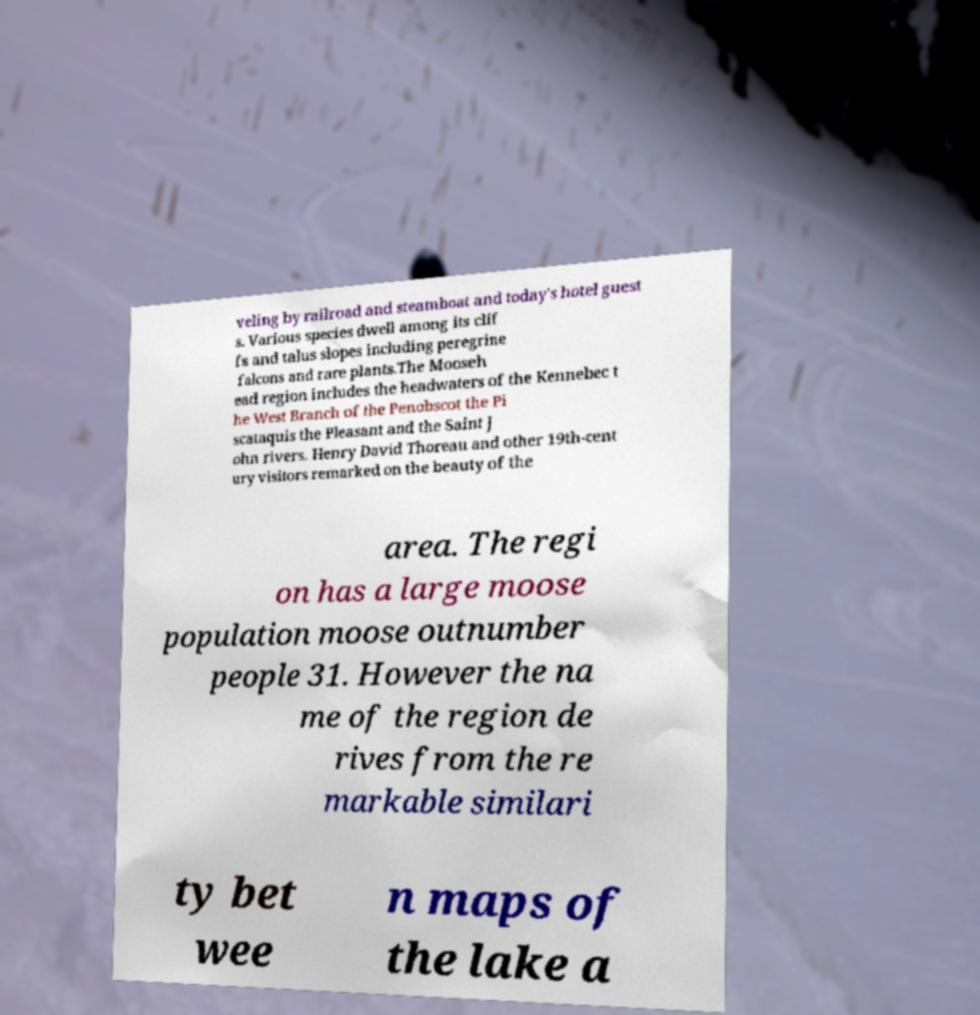What messages or text are displayed in this image? I need them in a readable, typed format. veling by railroad and steamboat and today's hotel guest s. Various species dwell among its clif fs and talus slopes including peregrine falcons and rare plants.The Mooseh ead region includes the headwaters of the Kennebec t he West Branch of the Penobscot the Pi scataquis the Pleasant and the Saint J ohn rivers. Henry David Thoreau and other 19th-cent ury visitors remarked on the beauty of the area. The regi on has a large moose population moose outnumber people 31. However the na me of the region de rives from the re markable similari ty bet wee n maps of the lake a 